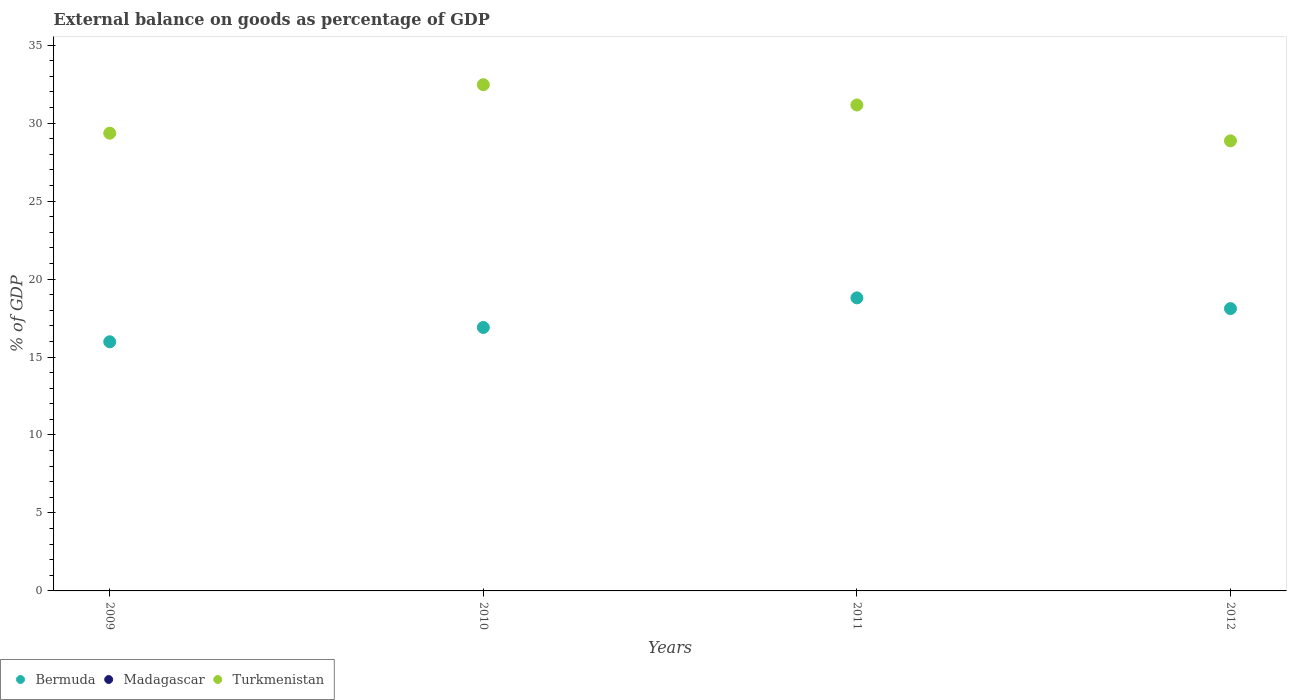Is the number of dotlines equal to the number of legend labels?
Keep it short and to the point. No. What is the external balance on goods as percentage of GDP in Madagascar in 2010?
Keep it short and to the point. 0. Across all years, what is the maximum external balance on goods as percentage of GDP in Bermuda?
Offer a very short reply. 18.79. Across all years, what is the minimum external balance on goods as percentage of GDP in Bermuda?
Your answer should be compact. 15.98. In which year was the external balance on goods as percentage of GDP in Bermuda maximum?
Provide a succinct answer. 2011. What is the difference between the external balance on goods as percentage of GDP in Bermuda in 2010 and that in 2012?
Offer a very short reply. -1.21. What is the difference between the external balance on goods as percentage of GDP in Bermuda in 2009 and the external balance on goods as percentage of GDP in Turkmenistan in 2010?
Provide a short and direct response. -16.49. In the year 2010, what is the difference between the external balance on goods as percentage of GDP in Turkmenistan and external balance on goods as percentage of GDP in Bermuda?
Offer a very short reply. 15.57. What is the ratio of the external balance on goods as percentage of GDP in Turkmenistan in 2010 to that in 2012?
Offer a very short reply. 1.12. Is the external balance on goods as percentage of GDP in Turkmenistan in 2010 less than that in 2011?
Provide a succinct answer. No. What is the difference between the highest and the second highest external balance on goods as percentage of GDP in Turkmenistan?
Make the answer very short. 1.3. What is the difference between the highest and the lowest external balance on goods as percentage of GDP in Turkmenistan?
Offer a very short reply. 3.6. In how many years, is the external balance on goods as percentage of GDP in Bermuda greater than the average external balance on goods as percentage of GDP in Bermuda taken over all years?
Give a very brief answer. 2. Is it the case that in every year, the sum of the external balance on goods as percentage of GDP in Turkmenistan and external balance on goods as percentage of GDP in Bermuda  is greater than the external balance on goods as percentage of GDP in Madagascar?
Offer a very short reply. Yes. Does the external balance on goods as percentage of GDP in Madagascar monotonically increase over the years?
Ensure brevity in your answer.  Yes. Is the external balance on goods as percentage of GDP in Turkmenistan strictly greater than the external balance on goods as percentage of GDP in Bermuda over the years?
Provide a short and direct response. Yes. Is the external balance on goods as percentage of GDP in Madagascar strictly less than the external balance on goods as percentage of GDP in Turkmenistan over the years?
Offer a terse response. Yes. How many dotlines are there?
Keep it short and to the point. 2. How many years are there in the graph?
Offer a very short reply. 4. Does the graph contain any zero values?
Your response must be concise. Yes. Does the graph contain grids?
Ensure brevity in your answer.  No. How many legend labels are there?
Give a very brief answer. 3. How are the legend labels stacked?
Make the answer very short. Horizontal. What is the title of the graph?
Offer a very short reply. External balance on goods as percentage of GDP. What is the label or title of the X-axis?
Give a very brief answer. Years. What is the label or title of the Y-axis?
Ensure brevity in your answer.  % of GDP. What is the % of GDP in Bermuda in 2009?
Keep it short and to the point. 15.98. What is the % of GDP of Madagascar in 2009?
Provide a succinct answer. 0. What is the % of GDP in Turkmenistan in 2009?
Offer a very short reply. 29.36. What is the % of GDP of Bermuda in 2010?
Offer a very short reply. 16.9. What is the % of GDP in Madagascar in 2010?
Your response must be concise. 0. What is the % of GDP of Turkmenistan in 2010?
Make the answer very short. 32.47. What is the % of GDP of Bermuda in 2011?
Give a very brief answer. 18.79. What is the % of GDP in Madagascar in 2011?
Keep it short and to the point. 0. What is the % of GDP in Turkmenistan in 2011?
Your answer should be compact. 31.16. What is the % of GDP in Bermuda in 2012?
Your answer should be very brief. 18.11. What is the % of GDP of Madagascar in 2012?
Ensure brevity in your answer.  0. What is the % of GDP of Turkmenistan in 2012?
Make the answer very short. 28.86. Across all years, what is the maximum % of GDP of Bermuda?
Offer a very short reply. 18.79. Across all years, what is the maximum % of GDP in Turkmenistan?
Provide a succinct answer. 32.47. Across all years, what is the minimum % of GDP of Bermuda?
Your answer should be very brief. 15.98. Across all years, what is the minimum % of GDP of Turkmenistan?
Make the answer very short. 28.86. What is the total % of GDP of Bermuda in the graph?
Make the answer very short. 69.78. What is the total % of GDP in Madagascar in the graph?
Make the answer very short. 0. What is the total % of GDP of Turkmenistan in the graph?
Offer a very short reply. 121.85. What is the difference between the % of GDP in Bermuda in 2009 and that in 2010?
Keep it short and to the point. -0.92. What is the difference between the % of GDP of Turkmenistan in 2009 and that in 2010?
Your answer should be very brief. -3.11. What is the difference between the % of GDP in Bermuda in 2009 and that in 2011?
Your answer should be compact. -2.82. What is the difference between the % of GDP in Turkmenistan in 2009 and that in 2011?
Ensure brevity in your answer.  -1.81. What is the difference between the % of GDP of Bermuda in 2009 and that in 2012?
Ensure brevity in your answer.  -2.13. What is the difference between the % of GDP of Turkmenistan in 2009 and that in 2012?
Offer a very short reply. 0.49. What is the difference between the % of GDP in Bermuda in 2010 and that in 2011?
Give a very brief answer. -1.9. What is the difference between the % of GDP in Turkmenistan in 2010 and that in 2011?
Ensure brevity in your answer.  1.3. What is the difference between the % of GDP of Bermuda in 2010 and that in 2012?
Make the answer very short. -1.21. What is the difference between the % of GDP in Turkmenistan in 2010 and that in 2012?
Offer a terse response. 3.6. What is the difference between the % of GDP of Bermuda in 2011 and that in 2012?
Give a very brief answer. 0.69. What is the difference between the % of GDP of Turkmenistan in 2011 and that in 2012?
Your response must be concise. 2.3. What is the difference between the % of GDP of Bermuda in 2009 and the % of GDP of Turkmenistan in 2010?
Ensure brevity in your answer.  -16.49. What is the difference between the % of GDP of Bermuda in 2009 and the % of GDP of Turkmenistan in 2011?
Your response must be concise. -15.19. What is the difference between the % of GDP of Bermuda in 2009 and the % of GDP of Turkmenistan in 2012?
Your answer should be very brief. -12.89. What is the difference between the % of GDP of Bermuda in 2010 and the % of GDP of Turkmenistan in 2011?
Your answer should be very brief. -14.27. What is the difference between the % of GDP of Bermuda in 2010 and the % of GDP of Turkmenistan in 2012?
Your answer should be compact. -11.97. What is the difference between the % of GDP of Bermuda in 2011 and the % of GDP of Turkmenistan in 2012?
Your answer should be compact. -10.07. What is the average % of GDP in Bermuda per year?
Your response must be concise. 17.44. What is the average % of GDP of Turkmenistan per year?
Provide a short and direct response. 30.46. In the year 2009, what is the difference between the % of GDP in Bermuda and % of GDP in Turkmenistan?
Provide a succinct answer. -13.38. In the year 2010, what is the difference between the % of GDP of Bermuda and % of GDP of Turkmenistan?
Offer a very short reply. -15.57. In the year 2011, what is the difference between the % of GDP in Bermuda and % of GDP in Turkmenistan?
Offer a terse response. -12.37. In the year 2012, what is the difference between the % of GDP in Bermuda and % of GDP in Turkmenistan?
Keep it short and to the point. -10.76. What is the ratio of the % of GDP of Bermuda in 2009 to that in 2010?
Provide a succinct answer. 0.95. What is the ratio of the % of GDP in Turkmenistan in 2009 to that in 2010?
Your response must be concise. 0.9. What is the ratio of the % of GDP of Bermuda in 2009 to that in 2011?
Make the answer very short. 0.85. What is the ratio of the % of GDP in Turkmenistan in 2009 to that in 2011?
Ensure brevity in your answer.  0.94. What is the ratio of the % of GDP of Bermuda in 2009 to that in 2012?
Provide a succinct answer. 0.88. What is the ratio of the % of GDP of Turkmenistan in 2009 to that in 2012?
Keep it short and to the point. 1.02. What is the ratio of the % of GDP in Bermuda in 2010 to that in 2011?
Your response must be concise. 0.9. What is the ratio of the % of GDP of Turkmenistan in 2010 to that in 2011?
Offer a very short reply. 1.04. What is the ratio of the % of GDP in Bermuda in 2010 to that in 2012?
Your response must be concise. 0.93. What is the ratio of the % of GDP in Turkmenistan in 2010 to that in 2012?
Ensure brevity in your answer.  1.12. What is the ratio of the % of GDP of Bermuda in 2011 to that in 2012?
Your answer should be very brief. 1.04. What is the ratio of the % of GDP in Turkmenistan in 2011 to that in 2012?
Offer a very short reply. 1.08. What is the difference between the highest and the second highest % of GDP of Bermuda?
Provide a short and direct response. 0.69. What is the difference between the highest and the second highest % of GDP of Turkmenistan?
Provide a short and direct response. 1.3. What is the difference between the highest and the lowest % of GDP of Bermuda?
Offer a very short reply. 2.82. What is the difference between the highest and the lowest % of GDP of Turkmenistan?
Your response must be concise. 3.6. 